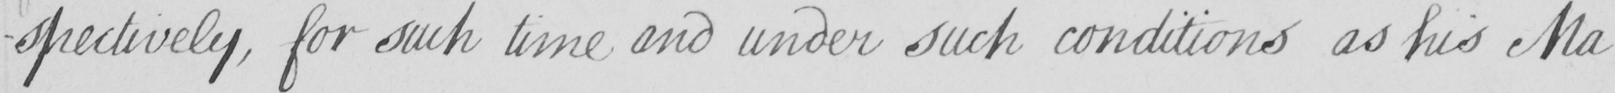What is written in this line of handwriting? -spectively , for such time and under such conditions as his Ma- 